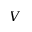<formula> <loc_0><loc_0><loc_500><loc_500>V</formula> 